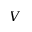<formula> <loc_0><loc_0><loc_500><loc_500>V</formula> 